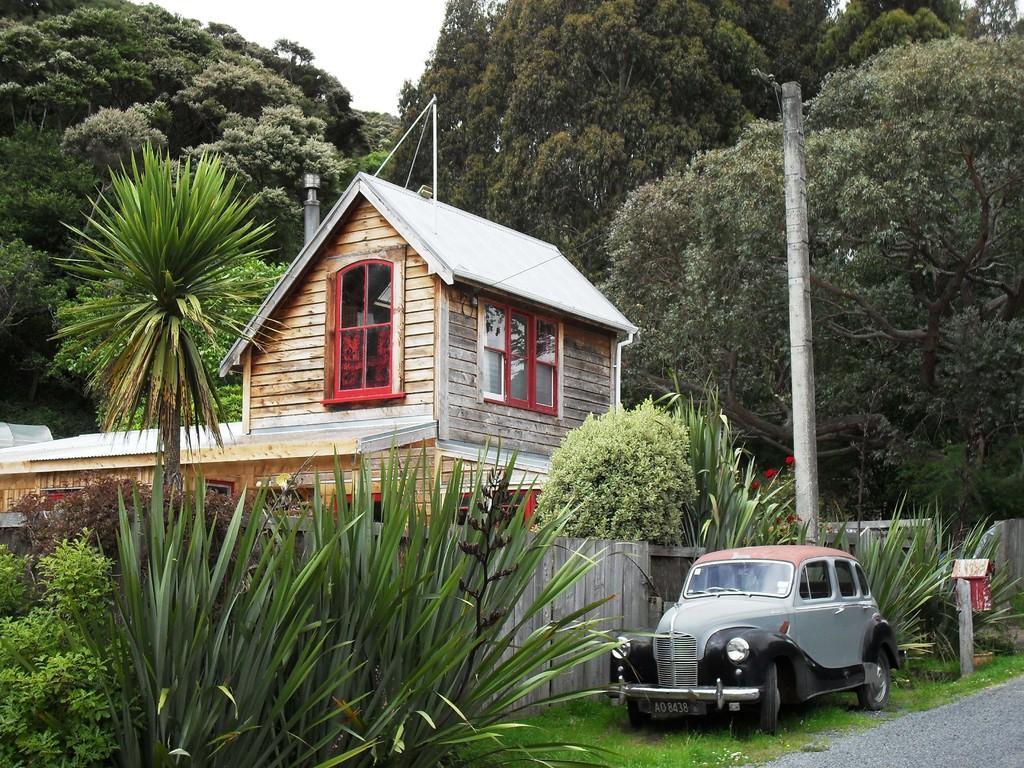Please provide a concise description of this image. In the center of the image we can see the sky, trees, one house, windows, one vehicle, plants, poles, grass and a road. 